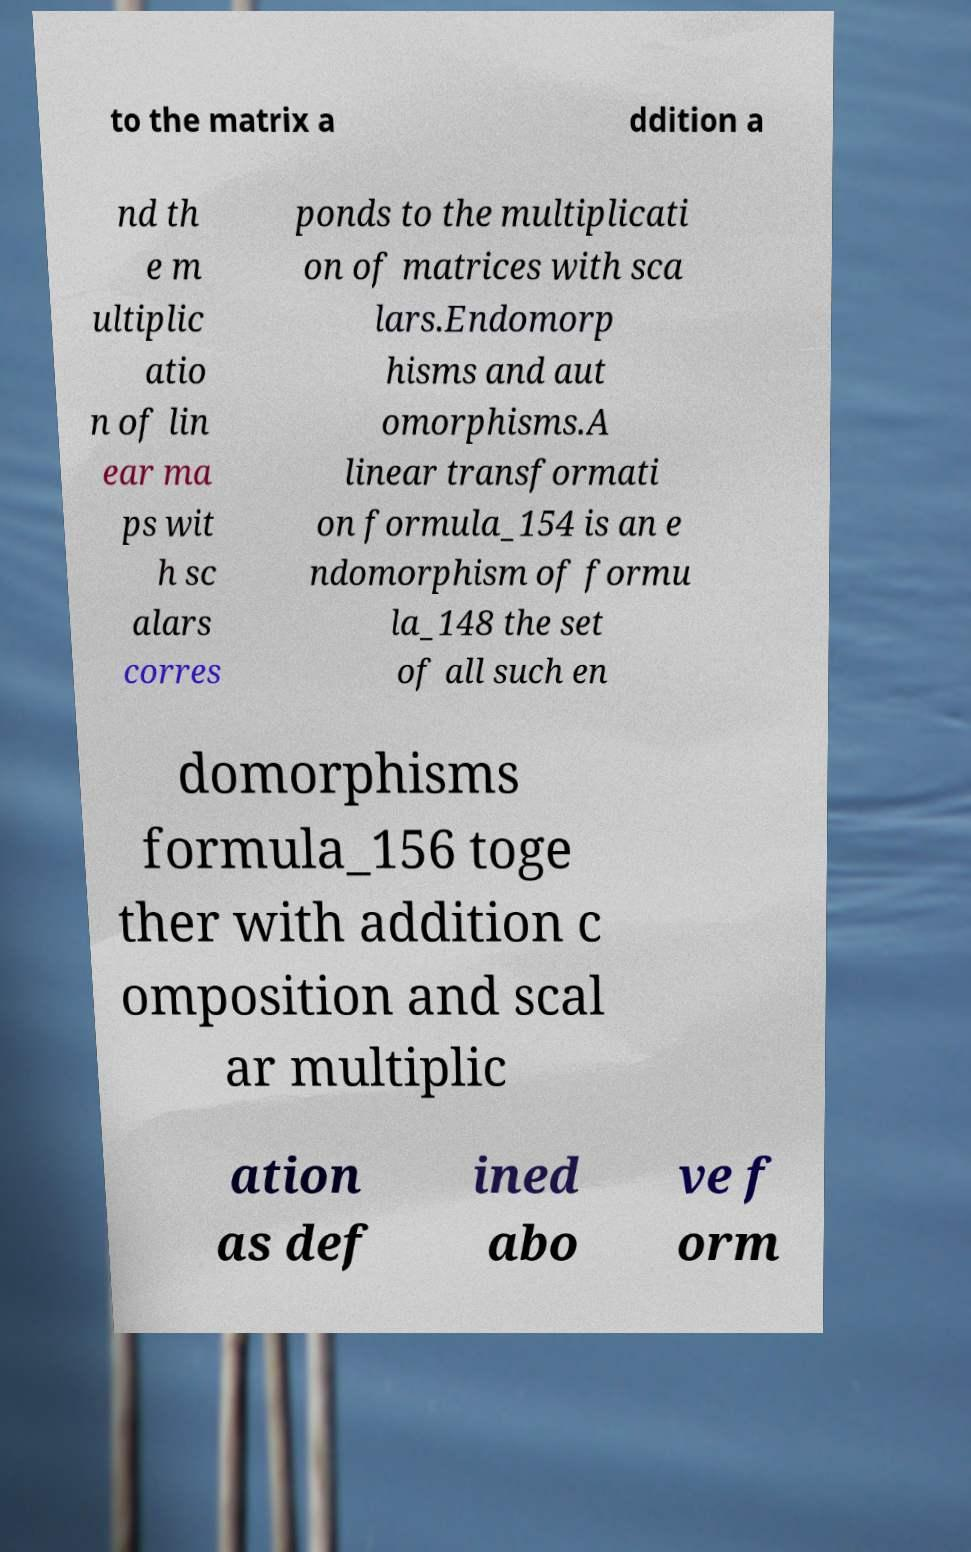I need the written content from this picture converted into text. Can you do that? to the matrix a ddition a nd th e m ultiplic atio n of lin ear ma ps wit h sc alars corres ponds to the multiplicati on of matrices with sca lars.Endomorp hisms and aut omorphisms.A linear transformati on formula_154 is an e ndomorphism of formu la_148 the set of all such en domorphisms formula_156 toge ther with addition c omposition and scal ar multiplic ation as def ined abo ve f orm 